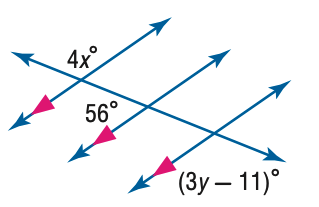Answer the mathemtical geometry problem and directly provide the correct option letter.
Question: Find y in the figure.
Choices: A: 35 B: 40 C: 45 D: 50 C 